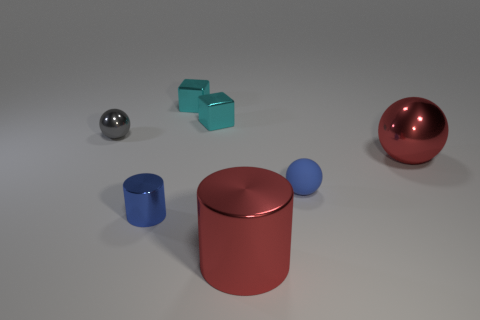Is there anything else that has the same size as the gray thing?
Your answer should be compact. Yes. Is the color of the tiny cylinder the same as the large ball?
Ensure brevity in your answer.  No. Is the number of red rubber blocks greater than the number of spheres?
Provide a succinct answer. No. What number of other objects are the same color as the tiny cylinder?
Keep it short and to the point. 1. There is a cylinder that is in front of the blue cylinder; how many small gray balls are left of it?
Keep it short and to the point. 1. Are there any metallic cylinders to the right of the large shiny ball?
Provide a short and direct response. No. There is a blue thing that is left of the tiny ball that is to the right of the tiny gray metal object; what shape is it?
Your answer should be compact. Cylinder. Are there fewer large red cylinders behind the big red cylinder than tiny blue matte things that are right of the big red shiny ball?
Make the answer very short. No. The big metallic object that is the same shape as the tiny gray object is what color?
Ensure brevity in your answer.  Red. How many small things are both to the right of the small blue shiny cylinder and behind the big red metallic ball?
Offer a terse response. 2. 